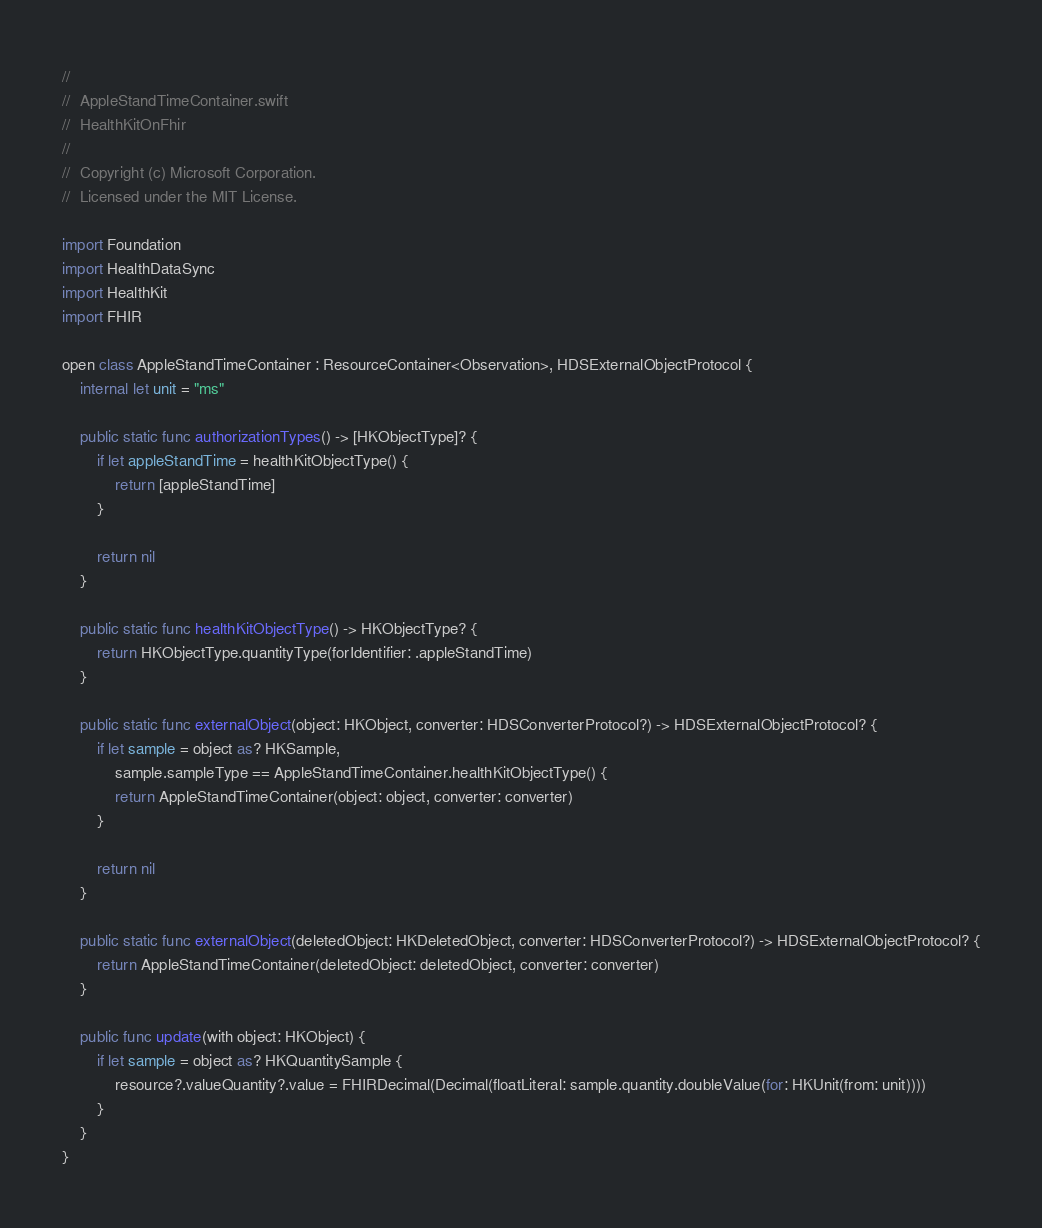<code> <loc_0><loc_0><loc_500><loc_500><_Swift_>//
//  AppleStandTimeContainer.swift
//  HealthKitOnFhir
//
//  Copyright (c) Microsoft Corporation.
//  Licensed under the MIT License.

import Foundation
import HealthDataSync
import HealthKit
import FHIR

open class AppleStandTimeContainer : ResourceContainer<Observation>, HDSExternalObjectProtocol {
    internal let unit = "ms"
    
    public static func authorizationTypes() -> [HKObjectType]? {
        if let appleStandTime = healthKitObjectType() {
            return [appleStandTime]
        }
        
        return nil
    }
    
    public static func healthKitObjectType() -> HKObjectType? {
        return HKObjectType.quantityType(forIdentifier: .appleStandTime)
    }
    
    public static func externalObject(object: HKObject, converter: HDSConverterProtocol?) -> HDSExternalObjectProtocol? {
        if let sample = object as? HKSample,
            sample.sampleType == AppleStandTimeContainer.healthKitObjectType() {
            return AppleStandTimeContainer(object: object, converter: converter)
        }
        
        return nil
    }
    
    public static func externalObject(deletedObject: HKDeletedObject, converter: HDSConverterProtocol?) -> HDSExternalObjectProtocol? {
        return AppleStandTimeContainer(deletedObject: deletedObject, converter: converter)
    }
    
    public func update(with object: HKObject) {
        if let sample = object as? HKQuantitySample {
            resource?.valueQuantity?.value = FHIRDecimal(Decimal(floatLiteral: sample.quantity.doubleValue(for: HKUnit(from: unit))))
        }
    }
}
</code> 